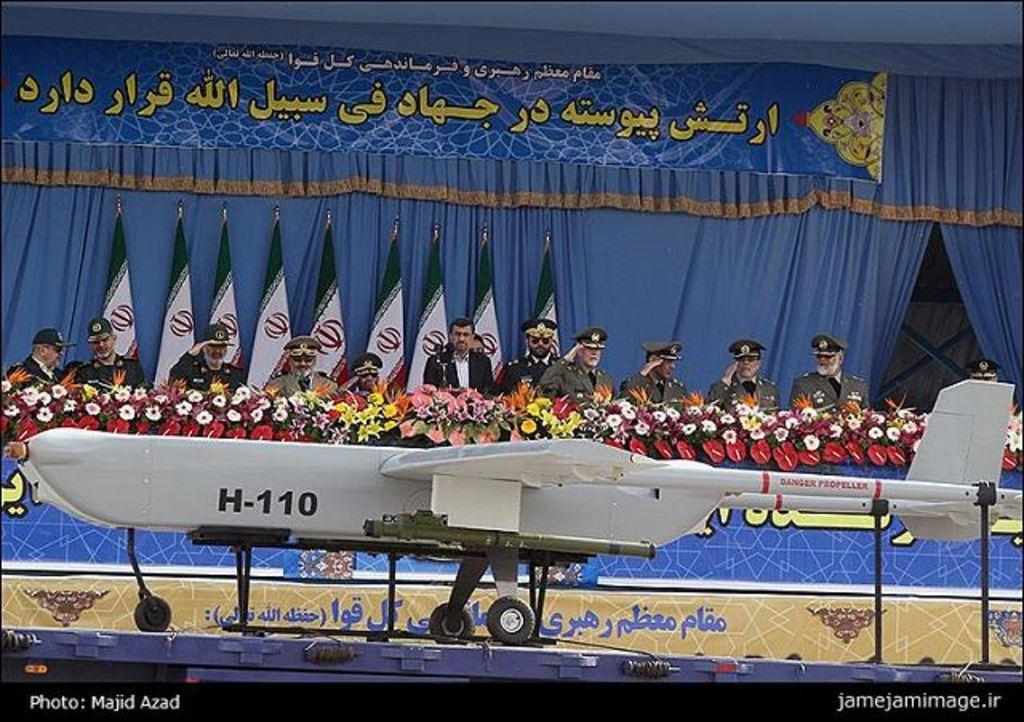What can be seen in the image involving multiple individuals? There is a group of people in the image. What type of flora is present in the image? There are flowers in multiple colors in the image. What mode of transportation is visible in the image? An aircraft is visible in the image. What color are the curtains in the background of the image? There are blue curtains in the background of the image. What type of jam is being served on the tray in the image? There is no tray or jam present in the image. How does the train move through the image? There is no train present in the image. 